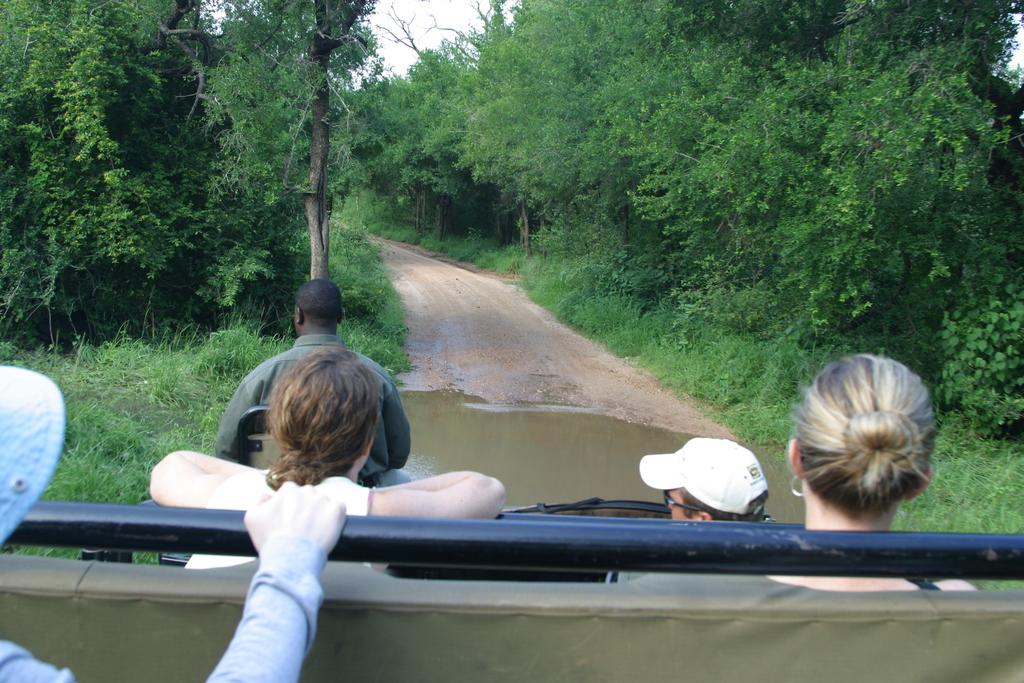What are the people doing in the image? The people are on a vehicle in the image. What is the condition of the road in the image? There is water on the road in the image. What type of vegetation can be seen in the image? There are trees and grass in the image. What is visible in the background of the image? The sky is visible in the background of the image. What type of cream is being applied to the trees in the image? There is no cream being applied to the trees in the image; the trees are simply present in the image. What type of train can be seen passing by in the image? There is no train present in the image; the main vehicle in the image is not a train. 